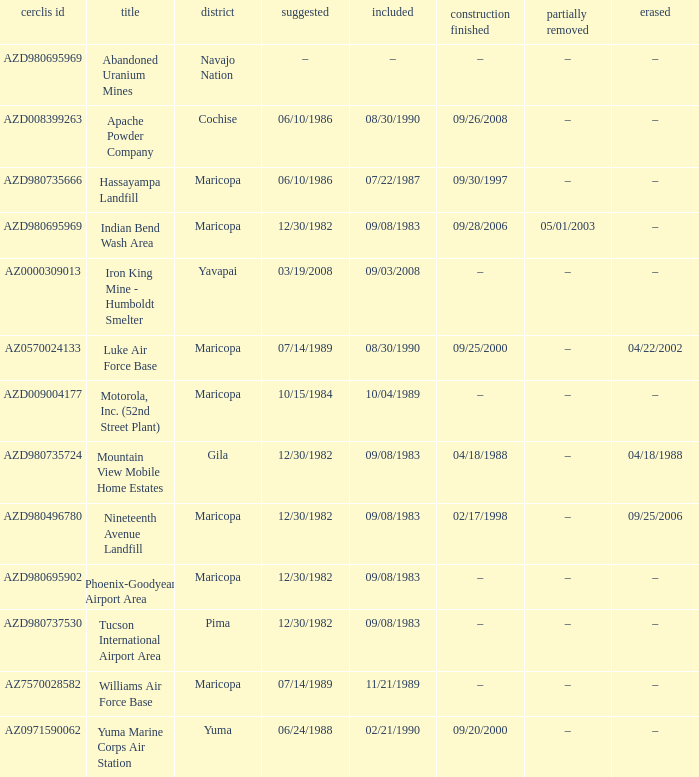What is the cerclis id when the site was proposed on 12/30/1982 and was partially deleted on 05/01/2003? AZD980695969. 